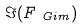<formula> <loc_0><loc_0><loc_500><loc_500>\Im ( F _ { \ G i m } )</formula> 